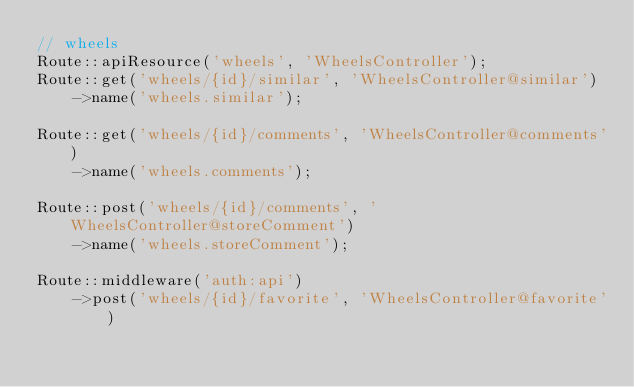Convert code to text. <code><loc_0><loc_0><loc_500><loc_500><_PHP_>// wheels
Route::apiResource('wheels', 'WheelsController');
Route::get('wheels/{id}/similar', 'WheelsController@similar')
    ->name('wheels.similar');

Route::get('wheels/{id}/comments', 'WheelsController@comments')
    ->name('wheels.comments');

Route::post('wheels/{id}/comments', 'WheelsController@storeComment')
    ->name('wheels.storeComment');

Route::middleware('auth:api')
    ->post('wheels/{id}/favorite', 'WheelsController@favorite')</code> 